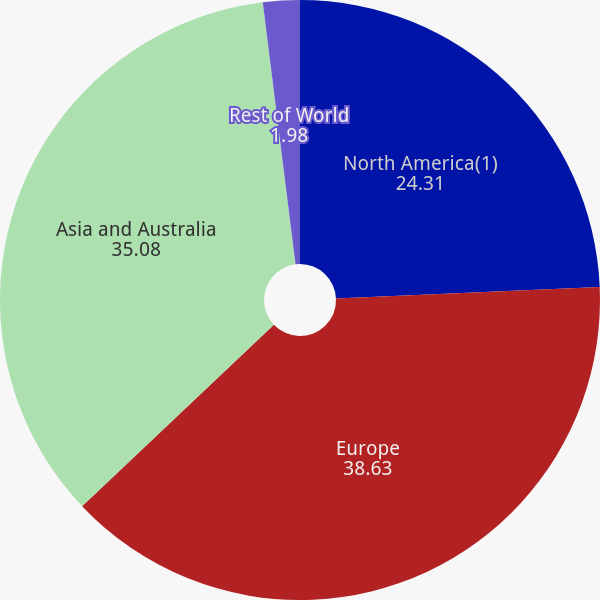Convert chart to OTSL. <chart><loc_0><loc_0><loc_500><loc_500><pie_chart><fcel>North America(1)<fcel>Europe<fcel>Asia and Australia<fcel>Rest of World<nl><fcel>24.31%<fcel>38.63%<fcel>35.08%<fcel>1.98%<nl></chart> 